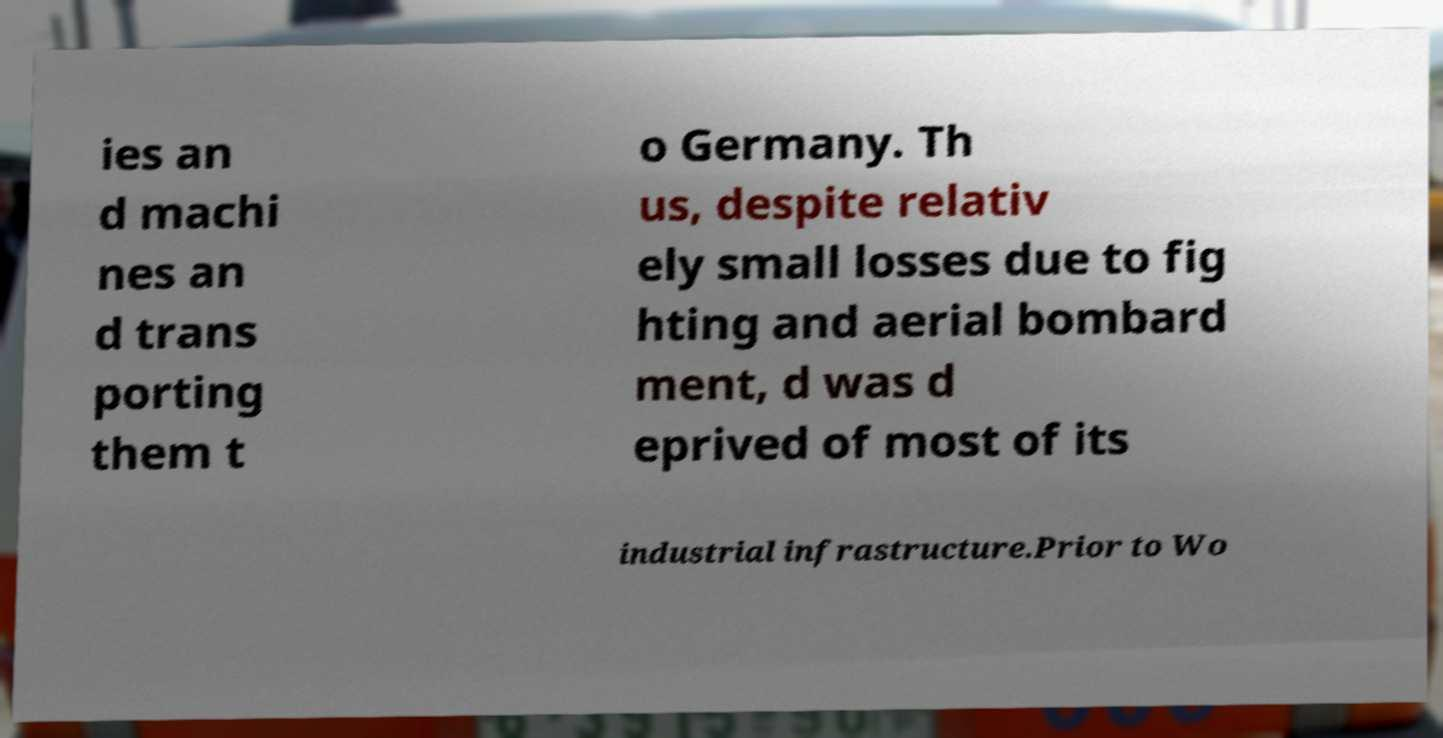Please read and relay the text visible in this image. What does it say? ies an d machi nes an d trans porting them t o Germany. Th us, despite relativ ely small losses due to fig hting and aerial bombard ment, d was d eprived of most of its industrial infrastructure.Prior to Wo 